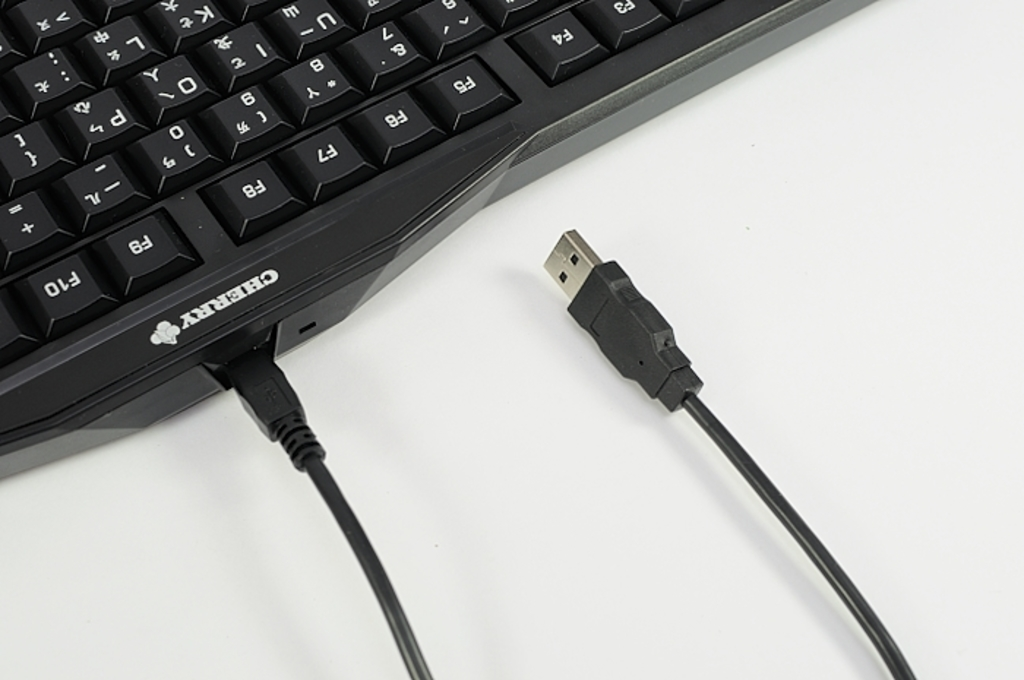Can you explain the significance of the USB cable in the image? The USB cable shown is crucial for connecting the keyboard to a computer, providing both power and data transmission capabilities required for the keyboard’s operation. What types of USB connectors exist other than the one shown? Beyond the USB type-A connector shown, other common types include USB type-B, Mini-USB, Micro-USB, and the newer USB type-C, which is reversible and supports faster data transfer and charging. 